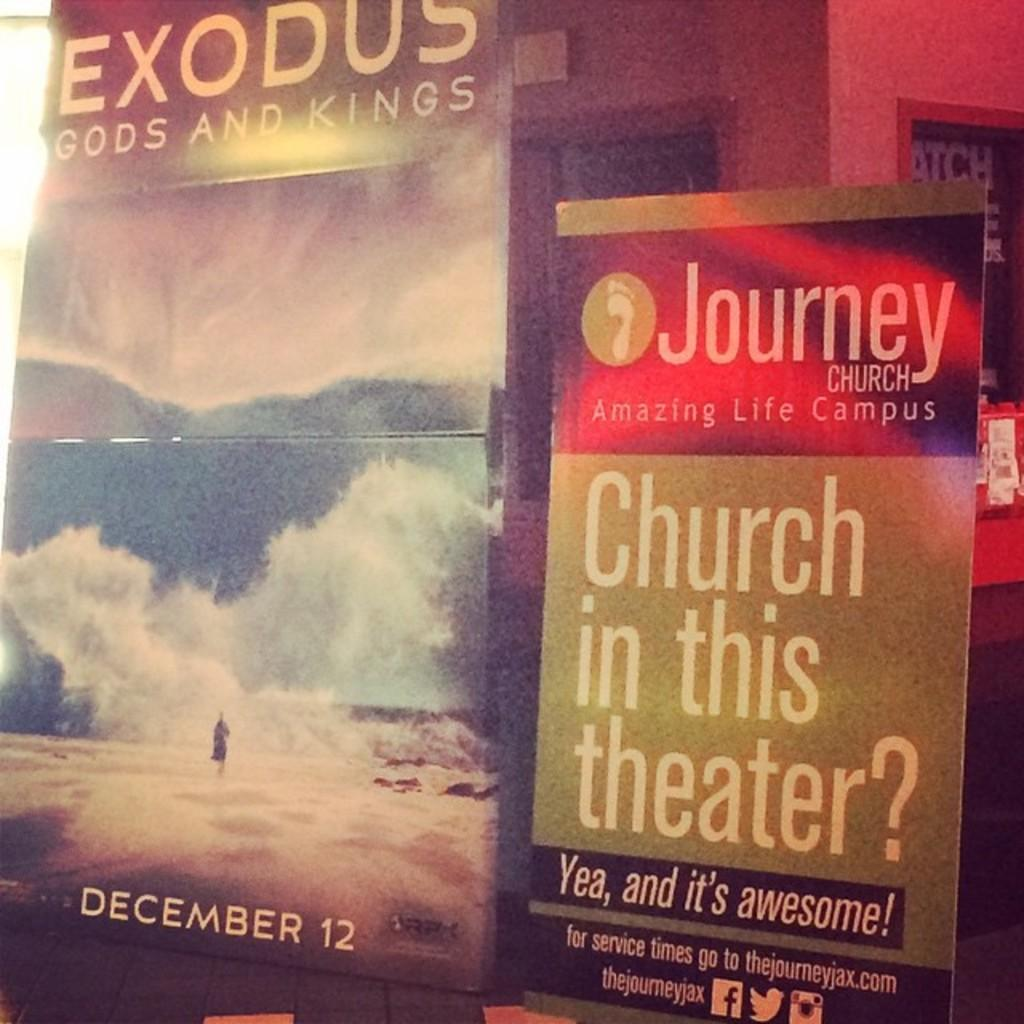<image>
Render a clear and concise summary of the photo. A church sign promoted Exodus Gods and Kings on December 12. 